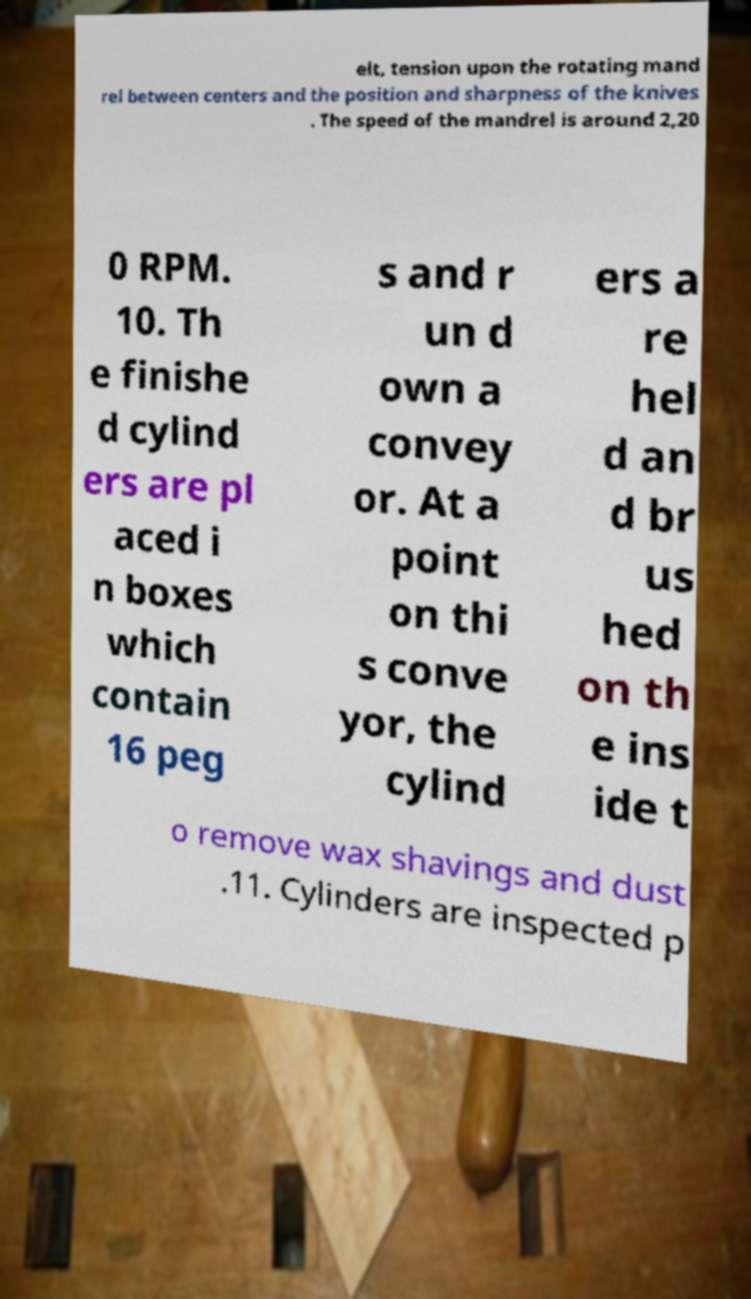For documentation purposes, I need the text within this image transcribed. Could you provide that? elt, tension upon the rotating mand rel between centers and the position and sharpness of the knives . The speed of the mandrel is around 2,20 0 RPM. 10. Th e finishe d cylind ers are pl aced i n boxes which contain 16 peg s and r un d own a convey or. At a point on thi s conve yor, the cylind ers a re hel d an d br us hed on th e ins ide t o remove wax shavings and dust .11. Cylinders are inspected p 